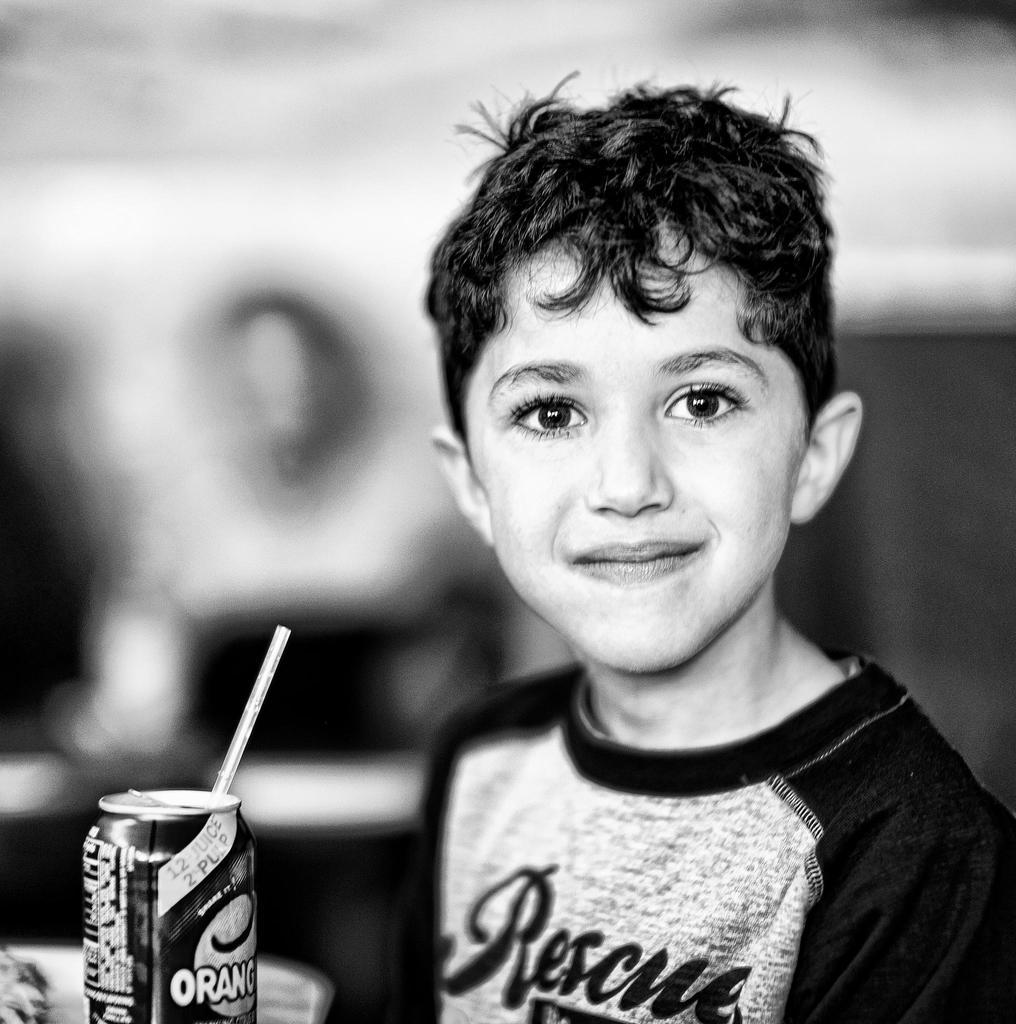Who is the main subject in the image? There is a boy in the image. Where is the boy located in the image? The boy is on the right side of the image. What is the boy wearing in the image? The boy is wearing a t-shirt. What object is present on the left side of the image? There is a tin with a straw in the image. What type of paste is being used by the boy in the image? There is no paste visible in the image, and the boy is not shown using any paste. 